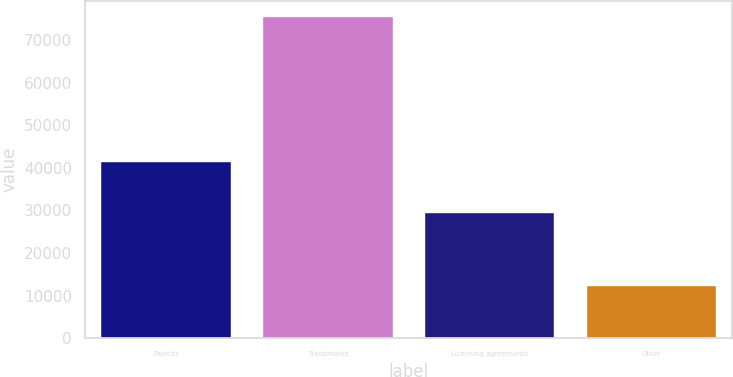Convert chart to OTSL. <chart><loc_0><loc_0><loc_500><loc_500><bar_chart><fcel>Patents<fcel>Trademarks<fcel>Licensing agreements<fcel>Other<nl><fcel>41353<fcel>75310<fcel>29490<fcel>12197<nl></chart> 